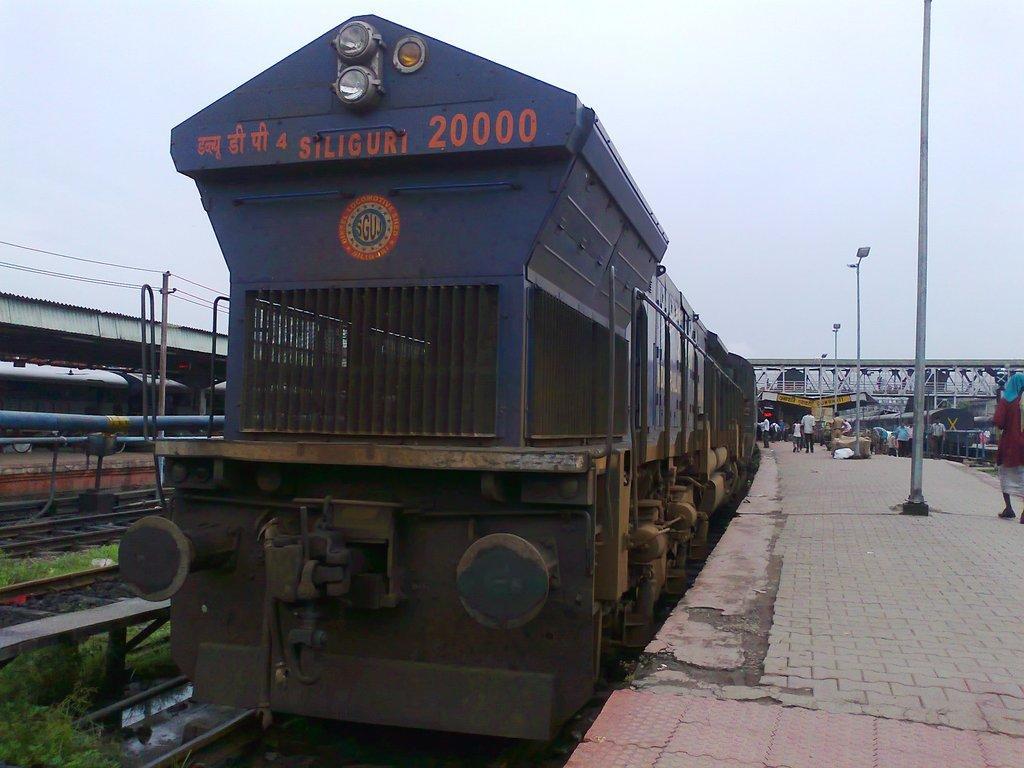Please provide a concise description of this image. In the middle it is a train on the railway track. On the right side it is the platform, few people are there. 